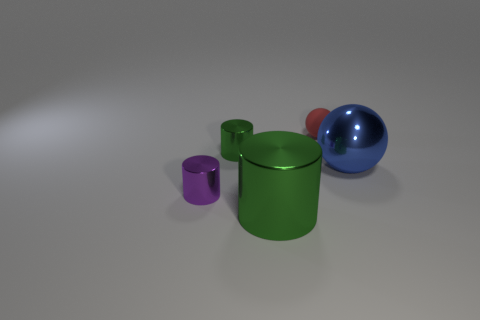Are there any other things that are made of the same material as the red ball?
Offer a terse response. No. Is the size of the metal object to the right of the red object the same as the matte ball?
Offer a very short reply. No. Is the number of balls that are to the left of the red thing greater than the number of tiny red objects?
Keep it short and to the point. No. Do the rubber thing and the blue thing have the same shape?
Provide a short and direct response. Yes. How big is the purple metal cylinder?
Your answer should be very brief. Small. Is the number of big spheres that are on the right side of the metallic ball greater than the number of purple shiny things that are behind the red sphere?
Provide a succinct answer. No. Are there any green metallic cylinders in front of the small green metal thing?
Ensure brevity in your answer.  Yes. Is there a green matte block that has the same size as the purple cylinder?
Ensure brevity in your answer.  No. The small cylinder that is the same material as the small green thing is what color?
Make the answer very short. Purple. What material is the blue object?
Your response must be concise. Metal. 